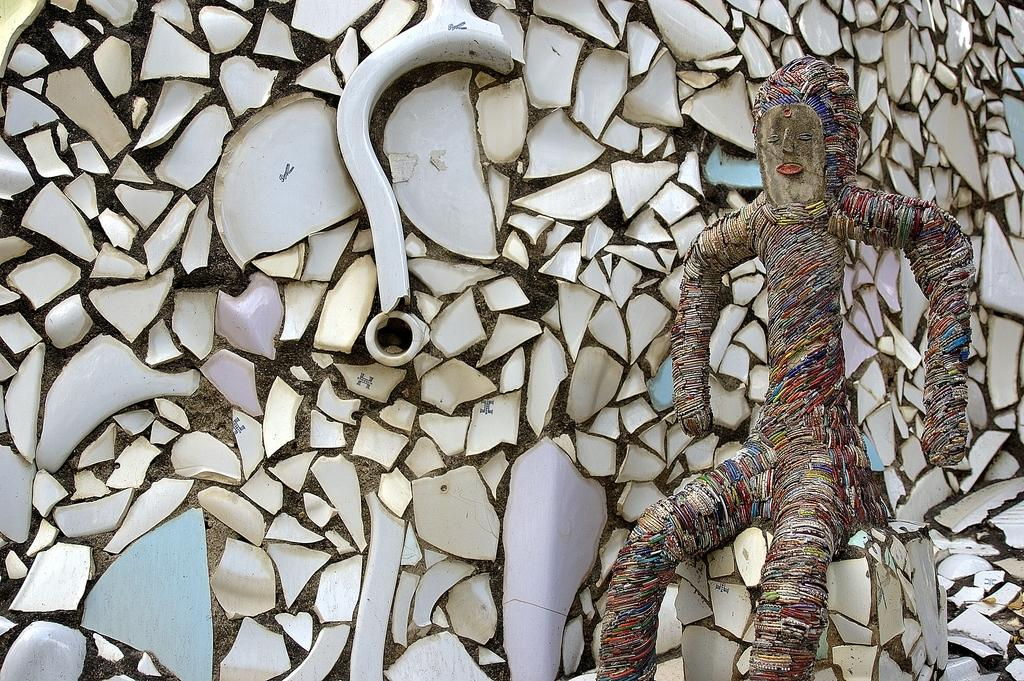What is the main subject of the image? There is a sculpture in the image. Can you describe the position of the sculpture? The sculpture is in a sitting position. What type of rat is depicted in the sculpture? There is no rat depicted in the sculpture; it is a sculpture of a figure in a sitting position. What is the growth rate of the sculpture in the image? The growth rate of the sculpture cannot be determined from the image, as it is a static object. 